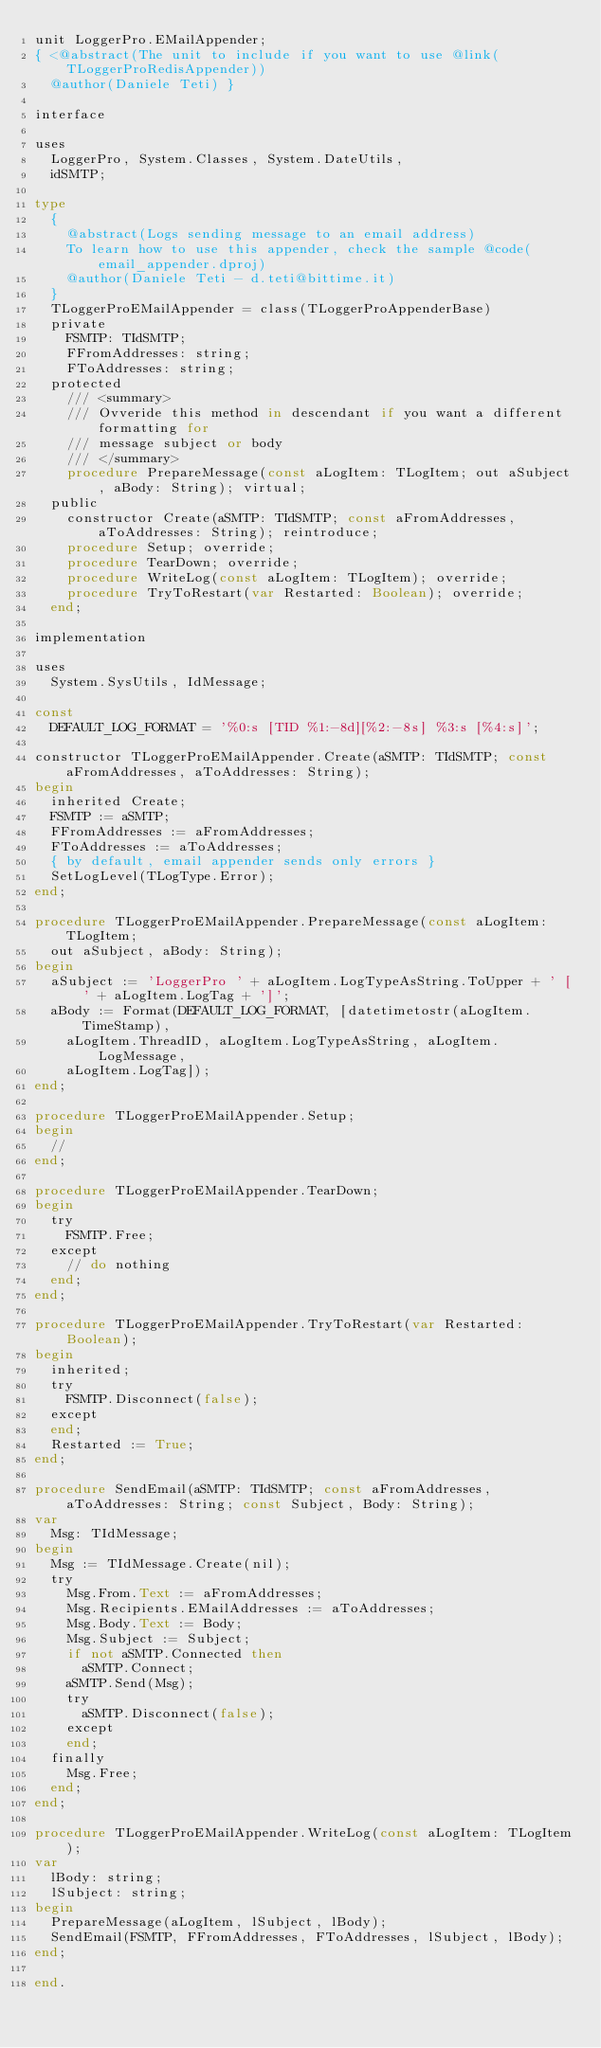Convert code to text. <code><loc_0><loc_0><loc_500><loc_500><_Pascal_>unit LoggerPro.EMailAppender;
{ <@abstract(The unit to include if you want to use @link(TLoggerProRedisAppender))
  @author(Daniele Teti) }

interface

uses
  LoggerPro, System.Classes, System.DateUtils,
  idSMTP;

type
  {
    @abstract(Logs sending message to an email address)
    To learn how to use this appender, check the sample @code(email_appender.dproj)
    @author(Daniele Teti - d.teti@bittime.it)
  }
  TLoggerProEMailAppender = class(TLoggerProAppenderBase)
  private
    FSMTP: TIdSMTP;
    FFromAddresses: string;
    FToAddresses: string;
  protected
    /// <summary>
    /// Ovveride this method in descendant if you want a different formatting for
    /// message subject or body
    /// </summary>
    procedure PrepareMessage(const aLogItem: TLogItem; out aSubject, aBody: String); virtual;
  public
    constructor Create(aSMTP: TIdSMTP; const aFromAddresses, aToAddresses: String); reintroduce;
    procedure Setup; override;
    procedure TearDown; override;
    procedure WriteLog(const aLogItem: TLogItem); override;
    procedure TryToRestart(var Restarted: Boolean); override;
  end;

implementation

uses
  System.SysUtils, IdMessage;

const
  DEFAULT_LOG_FORMAT = '%0:s [TID %1:-8d][%2:-8s] %3:s [%4:s]';

constructor TLoggerProEMailAppender.Create(aSMTP: TIdSMTP; const aFromAddresses, aToAddresses: String);
begin
  inherited Create;
  FSMTP := aSMTP;
  FFromAddresses := aFromAddresses;
  FToAddresses := aToAddresses;
  { by default, email appender sends only errors }
  SetLogLevel(TLogType.Error);
end;

procedure TLoggerProEMailAppender.PrepareMessage(const aLogItem: TLogItem;
  out aSubject, aBody: String);
begin
  aSubject := 'LoggerPro ' + aLogItem.LogTypeAsString.ToUpper + ' [' + aLogItem.LogTag + ']';
  aBody := Format(DEFAULT_LOG_FORMAT, [datetimetostr(aLogItem.TimeStamp),
    aLogItem.ThreadID, aLogItem.LogTypeAsString, aLogItem.LogMessage,
    aLogItem.LogTag]);
end;

procedure TLoggerProEMailAppender.Setup;
begin
  //
end;

procedure TLoggerProEMailAppender.TearDown;
begin
  try
    FSMTP.Free;
  except
    // do nothing
  end;
end;

procedure TLoggerProEMailAppender.TryToRestart(var Restarted: Boolean);
begin
  inherited;
  try
    FSMTP.Disconnect(false);
  except
  end;
  Restarted := True;
end;

procedure SendEmail(aSMTP: TIdSMTP; const aFromAddresses, aToAddresses: String; const Subject, Body: String);
var
  Msg: TIdMessage;
begin
  Msg := TIdMessage.Create(nil);
  try
    Msg.From.Text := aFromAddresses;
    Msg.Recipients.EMailAddresses := aToAddresses;
    Msg.Body.Text := Body;
    Msg.Subject := Subject;
    if not aSMTP.Connected then
      aSMTP.Connect;
    aSMTP.Send(Msg);
    try
      aSMTP.Disconnect(false);
    except
    end;
  finally
    Msg.Free;
  end;
end;

procedure TLoggerProEMailAppender.WriteLog(const aLogItem: TLogItem);
var
  lBody: string;
  lSubject: string;
begin
  PrepareMessage(aLogItem, lSubject, lBody);
  SendEmail(FSMTP, FFromAddresses, FToAddresses, lSubject, lBody);
end;

end.
</code> 